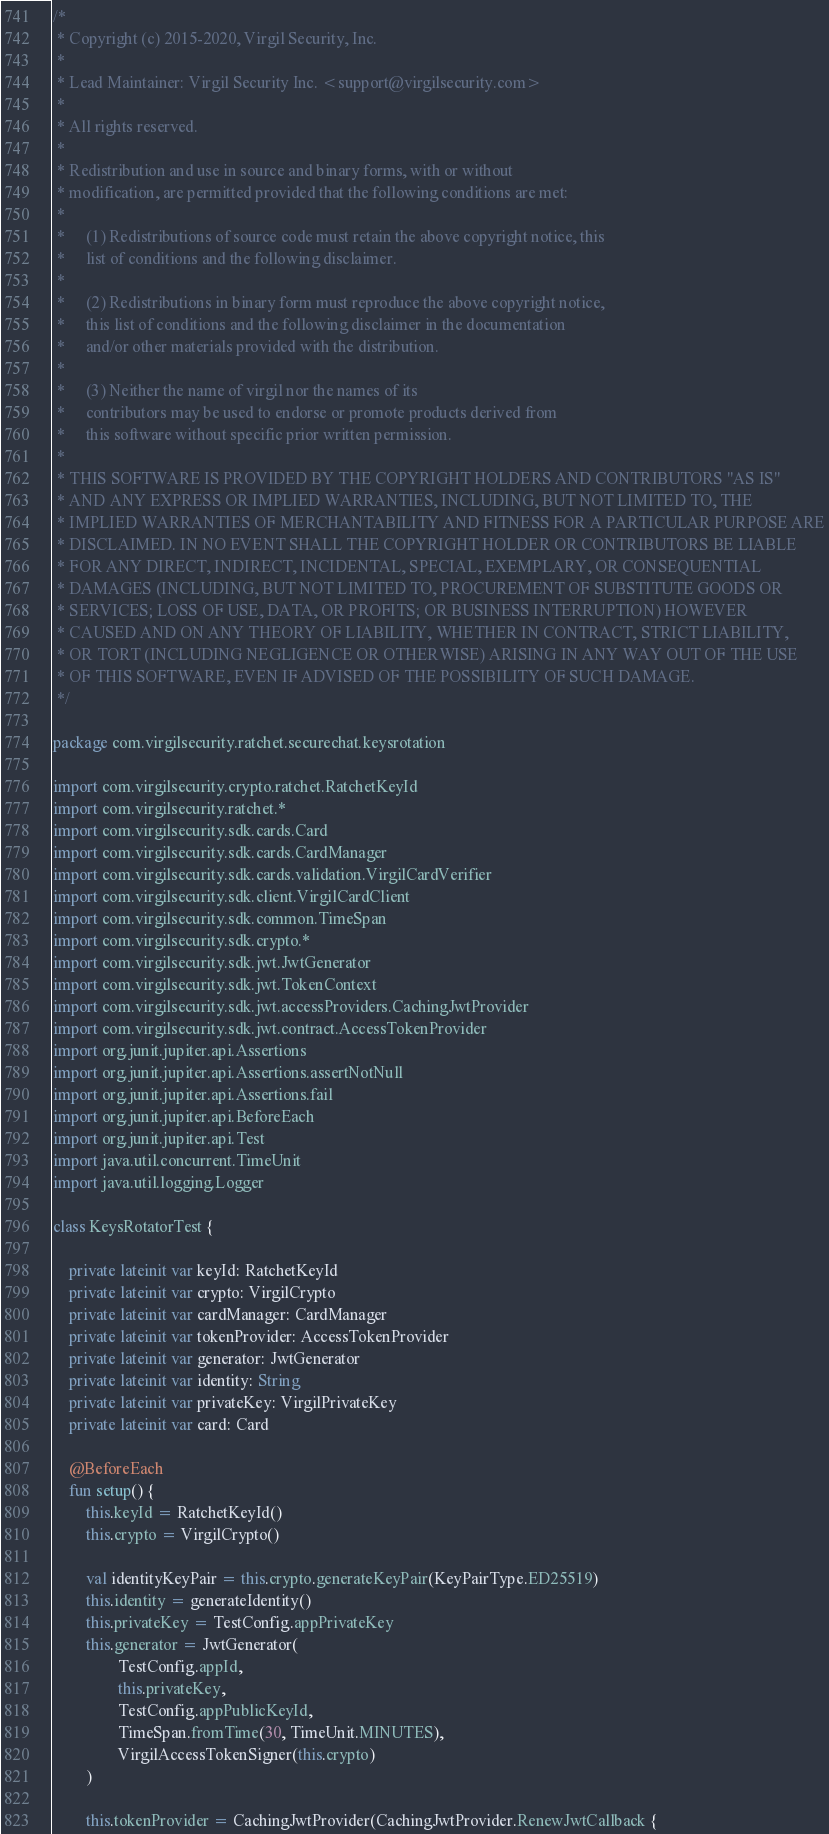<code> <loc_0><loc_0><loc_500><loc_500><_Kotlin_>/*
 * Copyright (c) 2015-2020, Virgil Security, Inc.
 *
 * Lead Maintainer: Virgil Security Inc. <support@virgilsecurity.com>
 *
 * All rights reserved.
 *
 * Redistribution and use in source and binary forms, with or without
 * modification, are permitted provided that the following conditions are met:
 *
 *     (1) Redistributions of source code must retain the above copyright notice, this
 *     list of conditions and the following disclaimer.
 *
 *     (2) Redistributions in binary form must reproduce the above copyright notice,
 *     this list of conditions and the following disclaimer in the documentation
 *     and/or other materials provided with the distribution.
 *
 *     (3) Neither the name of virgil nor the names of its
 *     contributors may be used to endorse or promote products derived from
 *     this software without specific prior written permission.
 *
 * THIS SOFTWARE IS PROVIDED BY THE COPYRIGHT HOLDERS AND CONTRIBUTORS "AS IS"
 * AND ANY EXPRESS OR IMPLIED WARRANTIES, INCLUDING, BUT NOT LIMITED TO, THE
 * IMPLIED WARRANTIES OF MERCHANTABILITY AND FITNESS FOR A PARTICULAR PURPOSE ARE
 * DISCLAIMED. IN NO EVENT SHALL THE COPYRIGHT HOLDER OR CONTRIBUTORS BE LIABLE
 * FOR ANY DIRECT, INDIRECT, INCIDENTAL, SPECIAL, EXEMPLARY, OR CONSEQUENTIAL
 * DAMAGES (INCLUDING, BUT NOT LIMITED TO, PROCUREMENT OF SUBSTITUTE GOODS OR
 * SERVICES; LOSS OF USE, DATA, OR PROFITS; OR BUSINESS INTERRUPTION) HOWEVER
 * CAUSED AND ON ANY THEORY OF LIABILITY, WHETHER IN CONTRACT, STRICT LIABILITY,
 * OR TORT (INCLUDING NEGLIGENCE OR OTHERWISE) ARISING IN ANY WAY OUT OF THE USE
 * OF THIS SOFTWARE, EVEN IF ADVISED OF THE POSSIBILITY OF SUCH DAMAGE.
 */

package com.virgilsecurity.ratchet.securechat.keysrotation

import com.virgilsecurity.crypto.ratchet.RatchetKeyId
import com.virgilsecurity.ratchet.*
import com.virgilsecurity.sdk.cards.Card
import com.virgilsecurity.sdk.cards.CardManager
import com.virgilsecurity.sdk.cards.validation.VirgilCardVerifier
import com.virgilsecurity.sdk.client.VirgilCardClient
import com.virgilsecurity.sdk.common.TimeSpan
import com.virgilsecurity.sdk.crypto.*
import com.virgilsecurity.sdk.jwt.JwtGenerator
import com.virgilsecurity.sdk.jwt.TokenContext
import com.virgilsecurity.sdk.jwt.accessProviders.CachingJwtProvider
import com.virgilsecurity.sdk.jwt.contract.AccessTokenProvider
import org.junit.jupiter.api.Assertions
import org.junit.jupiter.api.Assertions.assertNotNull
import org.junit.jupiter.api.Assertions.fail
import org.junit.jupiter.api.BeforeEach
import org.junit.jupiter.api.Test
import java.util.concurrent.TimeUnit
import java.util.logging.Logger

class KeysRotatorTest {

    private lateinit var keyId: RatchetKeyId
    private lateinit var crypto: VirgilCrypto
    private lateinit var cardManager: CardManager
    private lateinit var tokenProvider: AccessTokenProvider
    private lateinit var generator: JwtGenerator
    private lateinit var identity: String
    private lateinit var privateKey: VirgilPrivateKey
    private lateinit var card: Card

    @BeforeEach
    fun setup() {
        this.keyId = RatchetKeyId()
        this.crypto = VirgilCrypto()

        val identityKeyPair = this.crypto.generateKeyPair(KeyPairType.ED25519)
        this.identity = generateIdentity()
        this.privateKey = TestConfig.appPrivateKey
        this.generator = JwtGenerator(
                TestConfig.appId,
                this.privateKey,
                TestConfig.appPublicKeyId,
                TimeSpan.fromTime(30, TimeUnit.MINUTES),
                VirgilAccessTokenSigner(this.crypto)
        )

        this.tokenProvider = CachingJwtProvider(CachingJwtProvider.RenewJwtCallback {</code> 